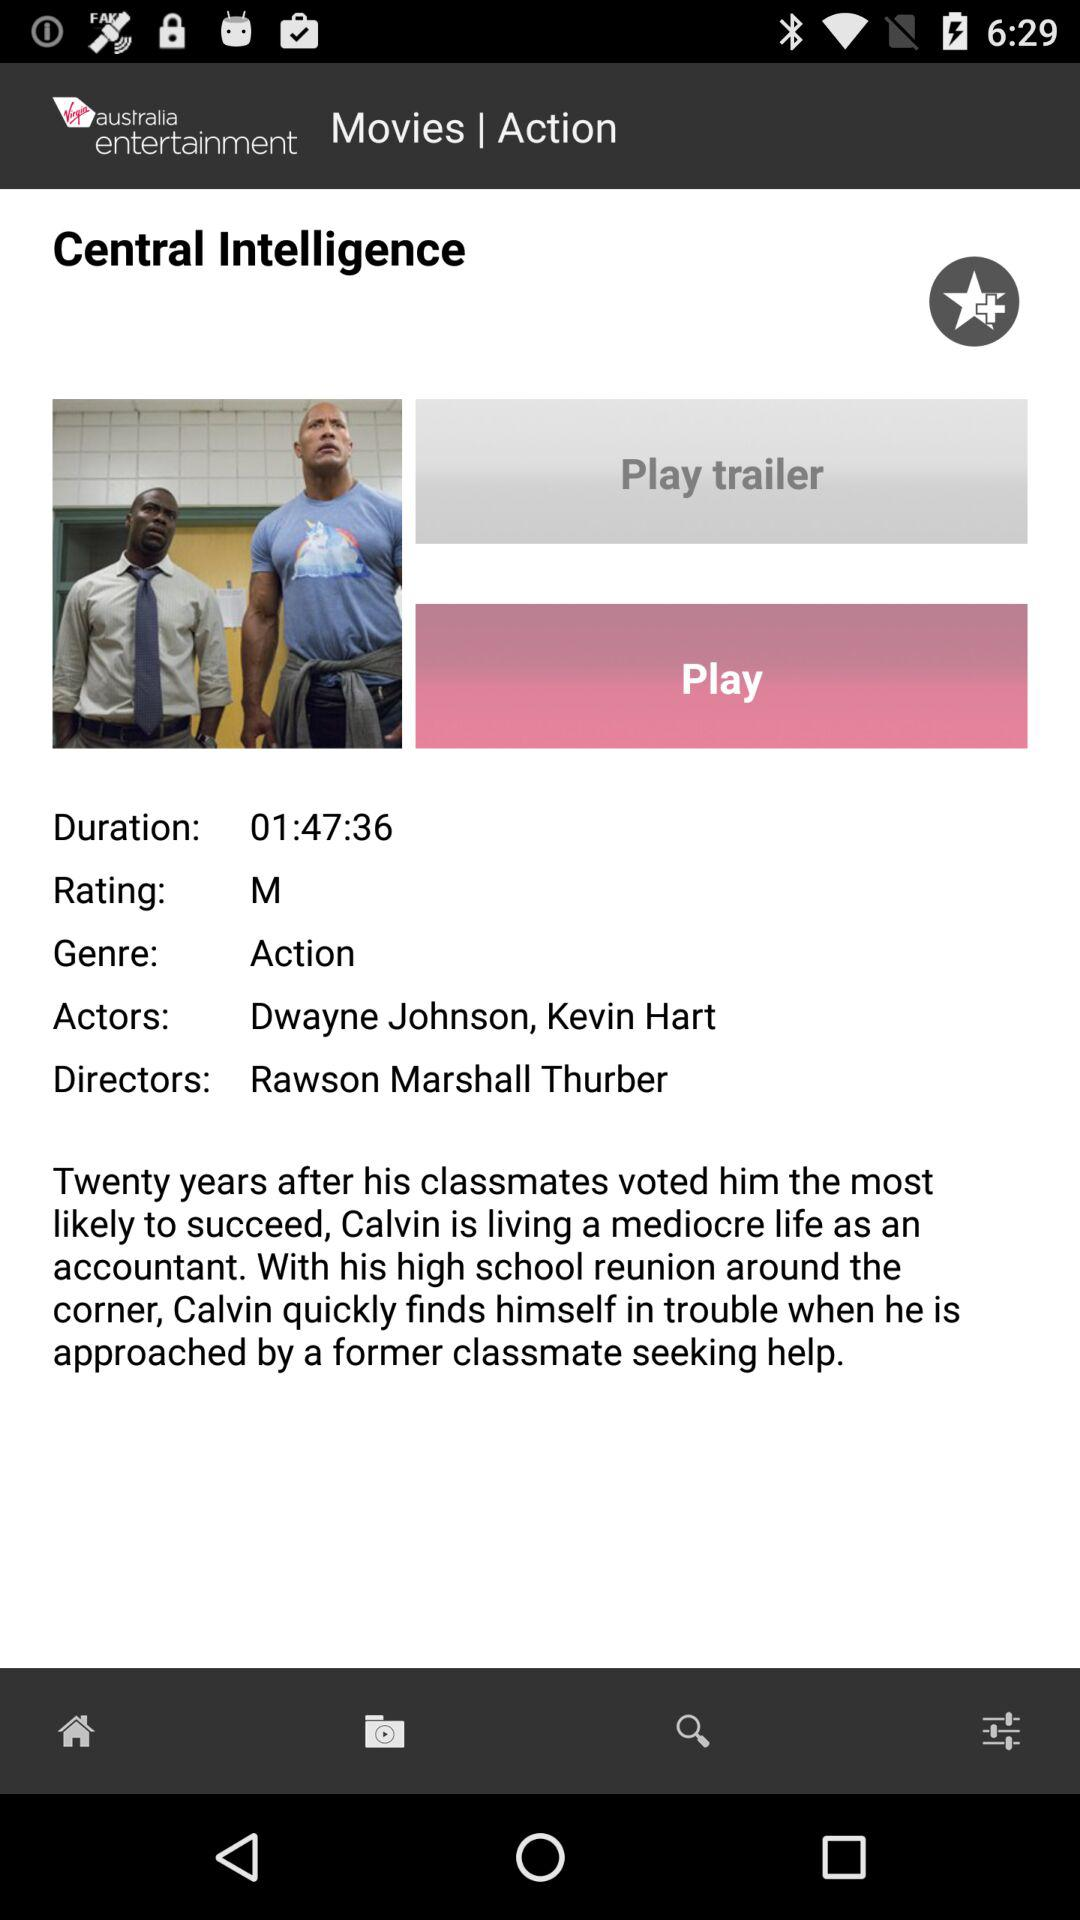What is the time duration of the movie? The time duration of the movie is 1 hour 47 minutes and 36 seconds. 